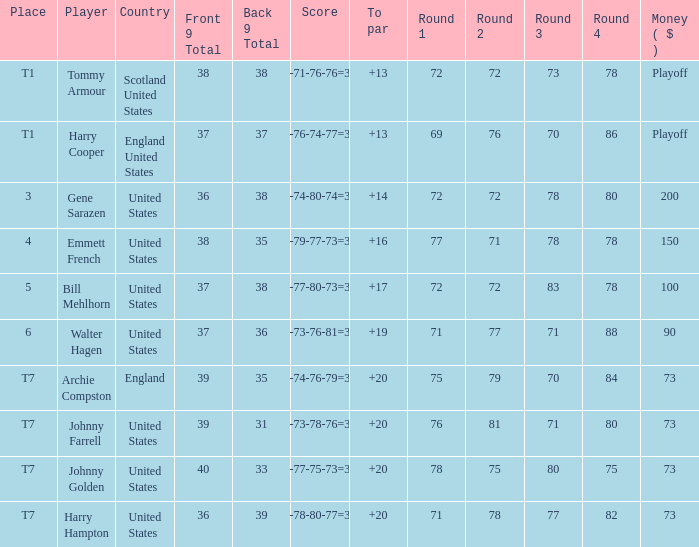What is the ranking for the United States when the money is $200? 3.0. 